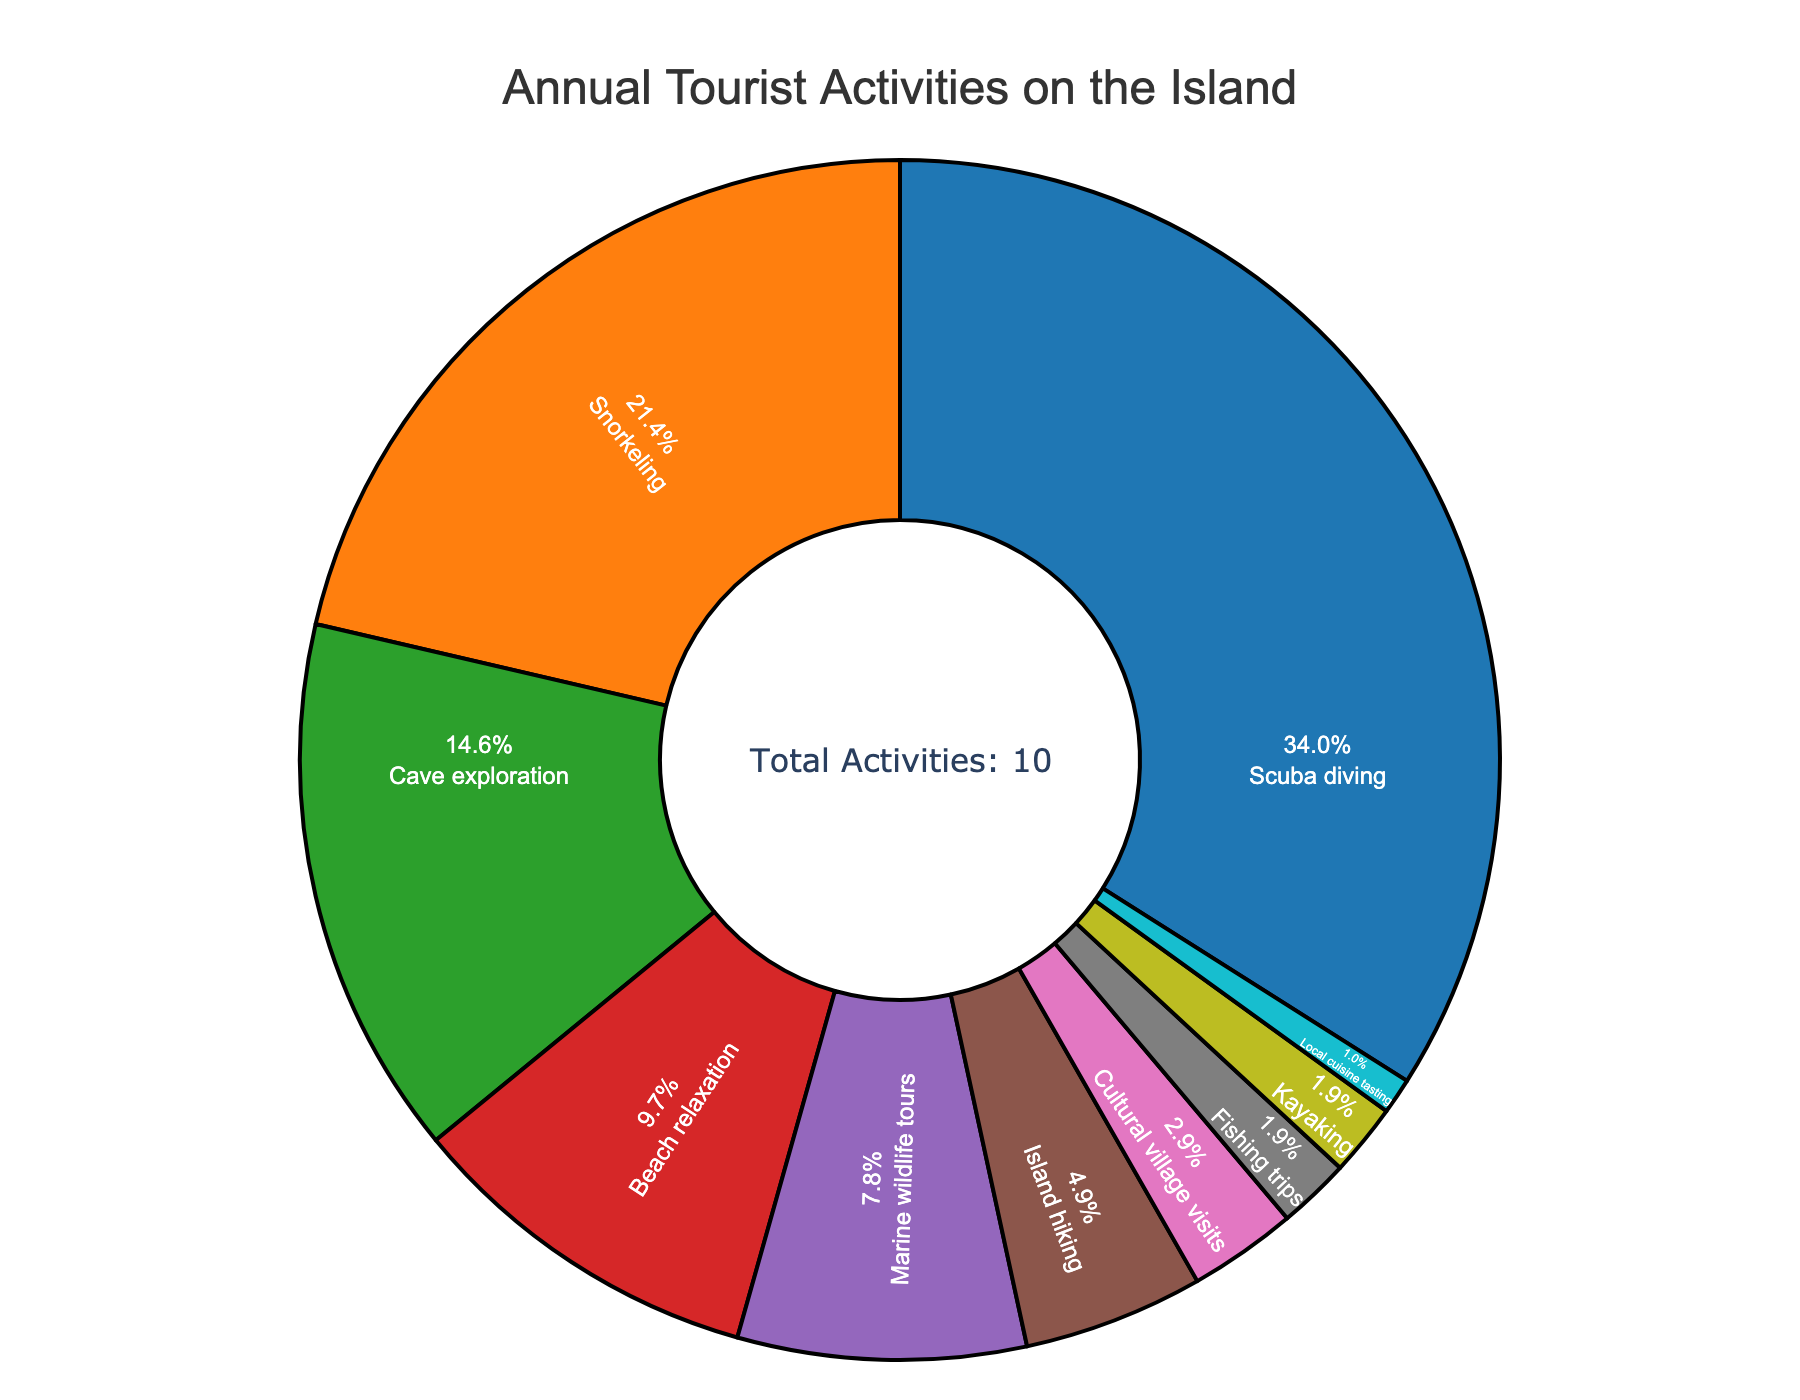What's the most popular tourist activity on the island? The pie chart shows various tourist activities with their corresponding percentage shares. The segment with the highest percentage indicates the most popular activity. In this chart, Scuba diving holds the largest percentage at 35%.
Answer: Scuba diving How much more popular is Scuba diving compared to Snorkeling? To find how much more popular Scuba diving is compared to Snorkeling, subtract the percentage of Snorkeling from the percentage of Scuba diving. Scuba diving is 35%, and Snorkeling is 22%. So, 35% - 22% = 13%.
Answer: 13% What's the combined percentage of tourists involved in water-related activities (Scuba diving, Snorkeling, Kayaking)? Adding the percentages of Scuba diving, Snorkeling, and Kayaking. Scuba diving has 35%, Snorkeling has 22%, and Kayaking has 2%. So, 35% + 22% + 2% = 59%.
Answer: 59% Which activity occupies the smallest segment on the pie chart? The smallest segment on the pie chart represents the activity with the lowest percentage. In this chart, Local cuisine tasting has the smallest segment with 1%.
Answer: Local cuisine tasting Are Marine wildlife tours more popular than Island hiking? To determine if Marine wildlife tours are more popular, compare their percentages. Marine wildlife tours have 8%, and Island hiking has 5%. Therefore, Marine wildlife tours are indeed more popular.
Answer: Yes What's the difference in popularity between Cave exploration and Beach relaxation? Subtract the percentage of Beach relaxation from Cave exploration. Cave exploration is 15%, and Beach relaxation is 10%. So, 15% - 10% = 5%.
Answer: 5% What's the combined percentage of tourists participating in Cave exploration and Cultural village visits? Add the percentages of Cave exploration and Cultural village visits. Cave exploration has 15%, and Cultural village visits have 3%. So, 15% + 3% = 18%.
Answer: 18% Which activity has a larger share, Fishing trips or Kayaking? Compare the percentages of Fishing trips and Kayaking. Both categories have the same percentage, 2%.
Answer: They are equal How many activities have a percentage greater than 10%? Identify the segments with percentages greater than 10%. The activities are Scuba diving (35%), Snorkeling (22%), and Cave exploration (15%). Therefore, there are 3 activities.
Answer: 3 What percentage of tourists are engaged in non-water-related activities (Cave exploration, Beach relaxation, Island hiking, Cultural village visits, Fishing trips, Local cuisine tasting)? Add the percentages of all non-water-related activities: Cave exploration (15%), Beach relaxation (10%), Island hiking (5%), Cultural village visits (3%), Fishing trips (2%), and Local cuisine tasting (1%). So, 15% + 10% + 5% + 3% + 2% + 1% = 36%.
Answer: 36% 